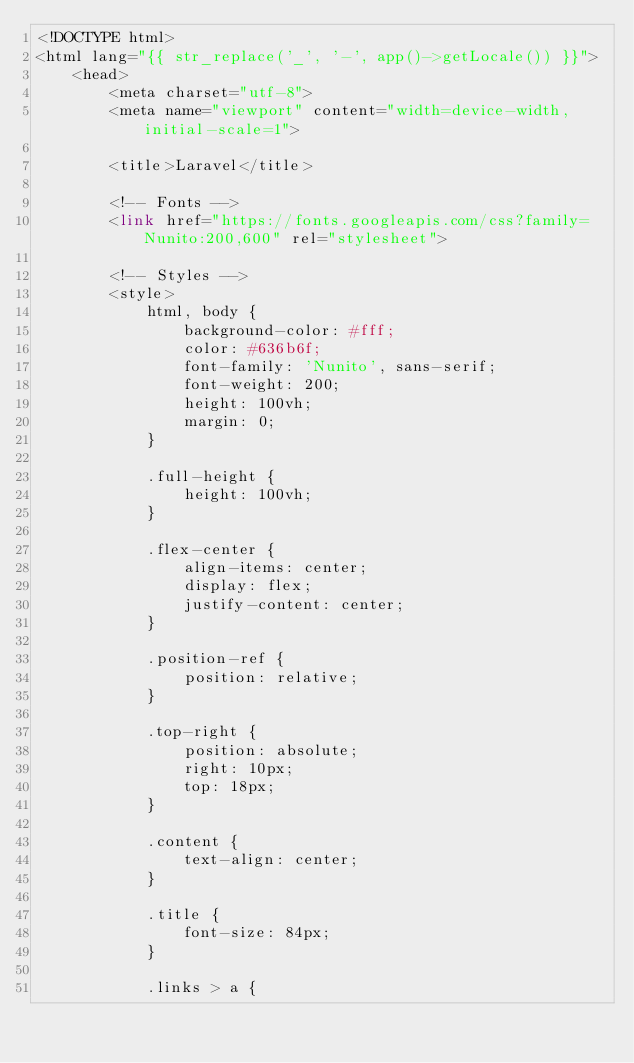Convert code to text. <code><loc_0><loc_0><loc_500><loc_500><_PHP_><!DOCTYPE html>
<html lang="{{ str_replace('_', '-', app()->getLocale()) }}">
    <head>
        <meta charset="utf-8">
        <meta name="viewport" content="width=device-width, initial-scale=1">

        <title>Laravel</title>

        <!-- Fonts -->
        <link href="https://fonts.googleapis.com/css?family=Nunito:200,600" rel="stylesheet">

        <!-- Styles -->
        <style>
            html, body {
                background-color: #fff;
                color: #636b6f;
                font-family: 'Nunito', sans-serif;
                font-weight: 200;
                height: 100vh;
                margin: 0;
            }

            .full-height {
                height: 100vh;
            }

            .flex-center {
                align-items: center;
                display: flex;
                justify-content: center;
            }

            .position-ref {
                position: relative;
            }

            .top-right {
                position: absolute;
                right: 10px;
                top: 18px;
            }

            .content {
                text-align: center;
            }

            .title {
                font-size: 84px;
            }

            .links > a {</code> 